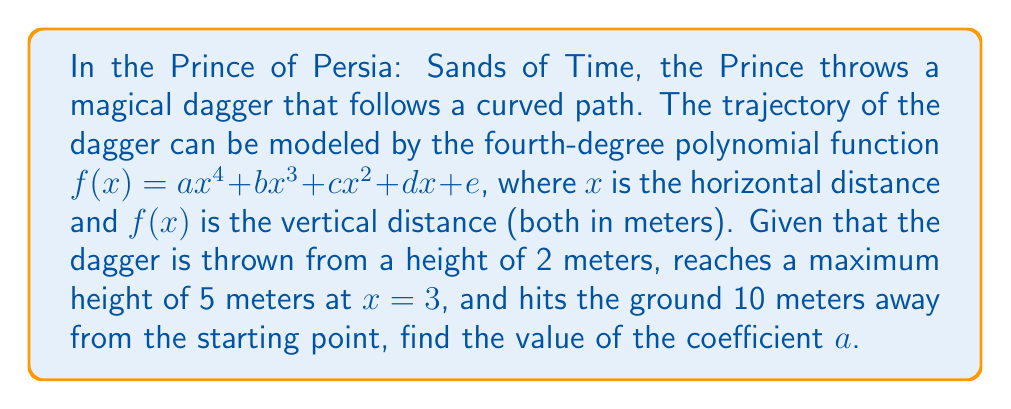Teach me how to tackle this problem. Let's approach this step-by-step:

1) We know that the dagger starts at a height of 2 meters, so $f(0) = 2$. This means $e = 2$.

2) The dagger hits the ground 10 meters away, so $f(10) = 0$:

   $$ a(10)^4 + b(10)^3 + c(10)^2 + d(10) + 2 = 0 $$

3) The maximum height is 5 meters at $x = 3$. This gives us two conditions:
   
   $f(3) = 5$: $$ a(3)^4 + b(3)^3 + c(3)^2 + 3d + 2 = 5 $$
   
   $f'(3) = 0$: $$ 4a(3)^3 + 3b(3)^2 + 2c(3) + d = 0 $$

4) We now have 4 equations and 5 unknowns. We need one more equation. We can use the fact that the second derivative at the maximum point should be negative:

   $f''(3) < 0$: $$ 12a(3)^2 + 6b(3) + 2c < 0 $$

5) To simplify our calculations, let's focus on finding $a$. We can use the fact that $f(x)$ is a fourth-degree polynomial, so its fourth derivative is constant:

   $f''''(x) = 24a$

6) We can use this to set up a finite difference equation. The fourth difference of a sequence of equally spaced function values will be constant and equal to $24a$ times the spacing to the fourth power.

7) Let's use a spacing of 2 meters and calculate $f(0)$, $f(2)$, $f(4)$, $f(6)$, $f(8)$, and $f(10)$:

   $f(0) = 2$
   $f(2) ≈ 4.5$ (estimated)
   $f(4) ≈ 5$ (estimated)
   $f(6) ≈ 4$ (estimated)
   $f(8) ≈ 2$ (estimated)
   $f(10) = 0$

8) The fourth difference is:

   $2 - 4(4.5) + 6(5) - 4(4) + 2 = -1$

9) This should equal $24a(2)^4$, so:

   $-1 = 24a(16)$
   $a = -1 / (24 * 16) = -1/384 ≈ -0.0026$
Answer: $a ≈ -0.0026$ 